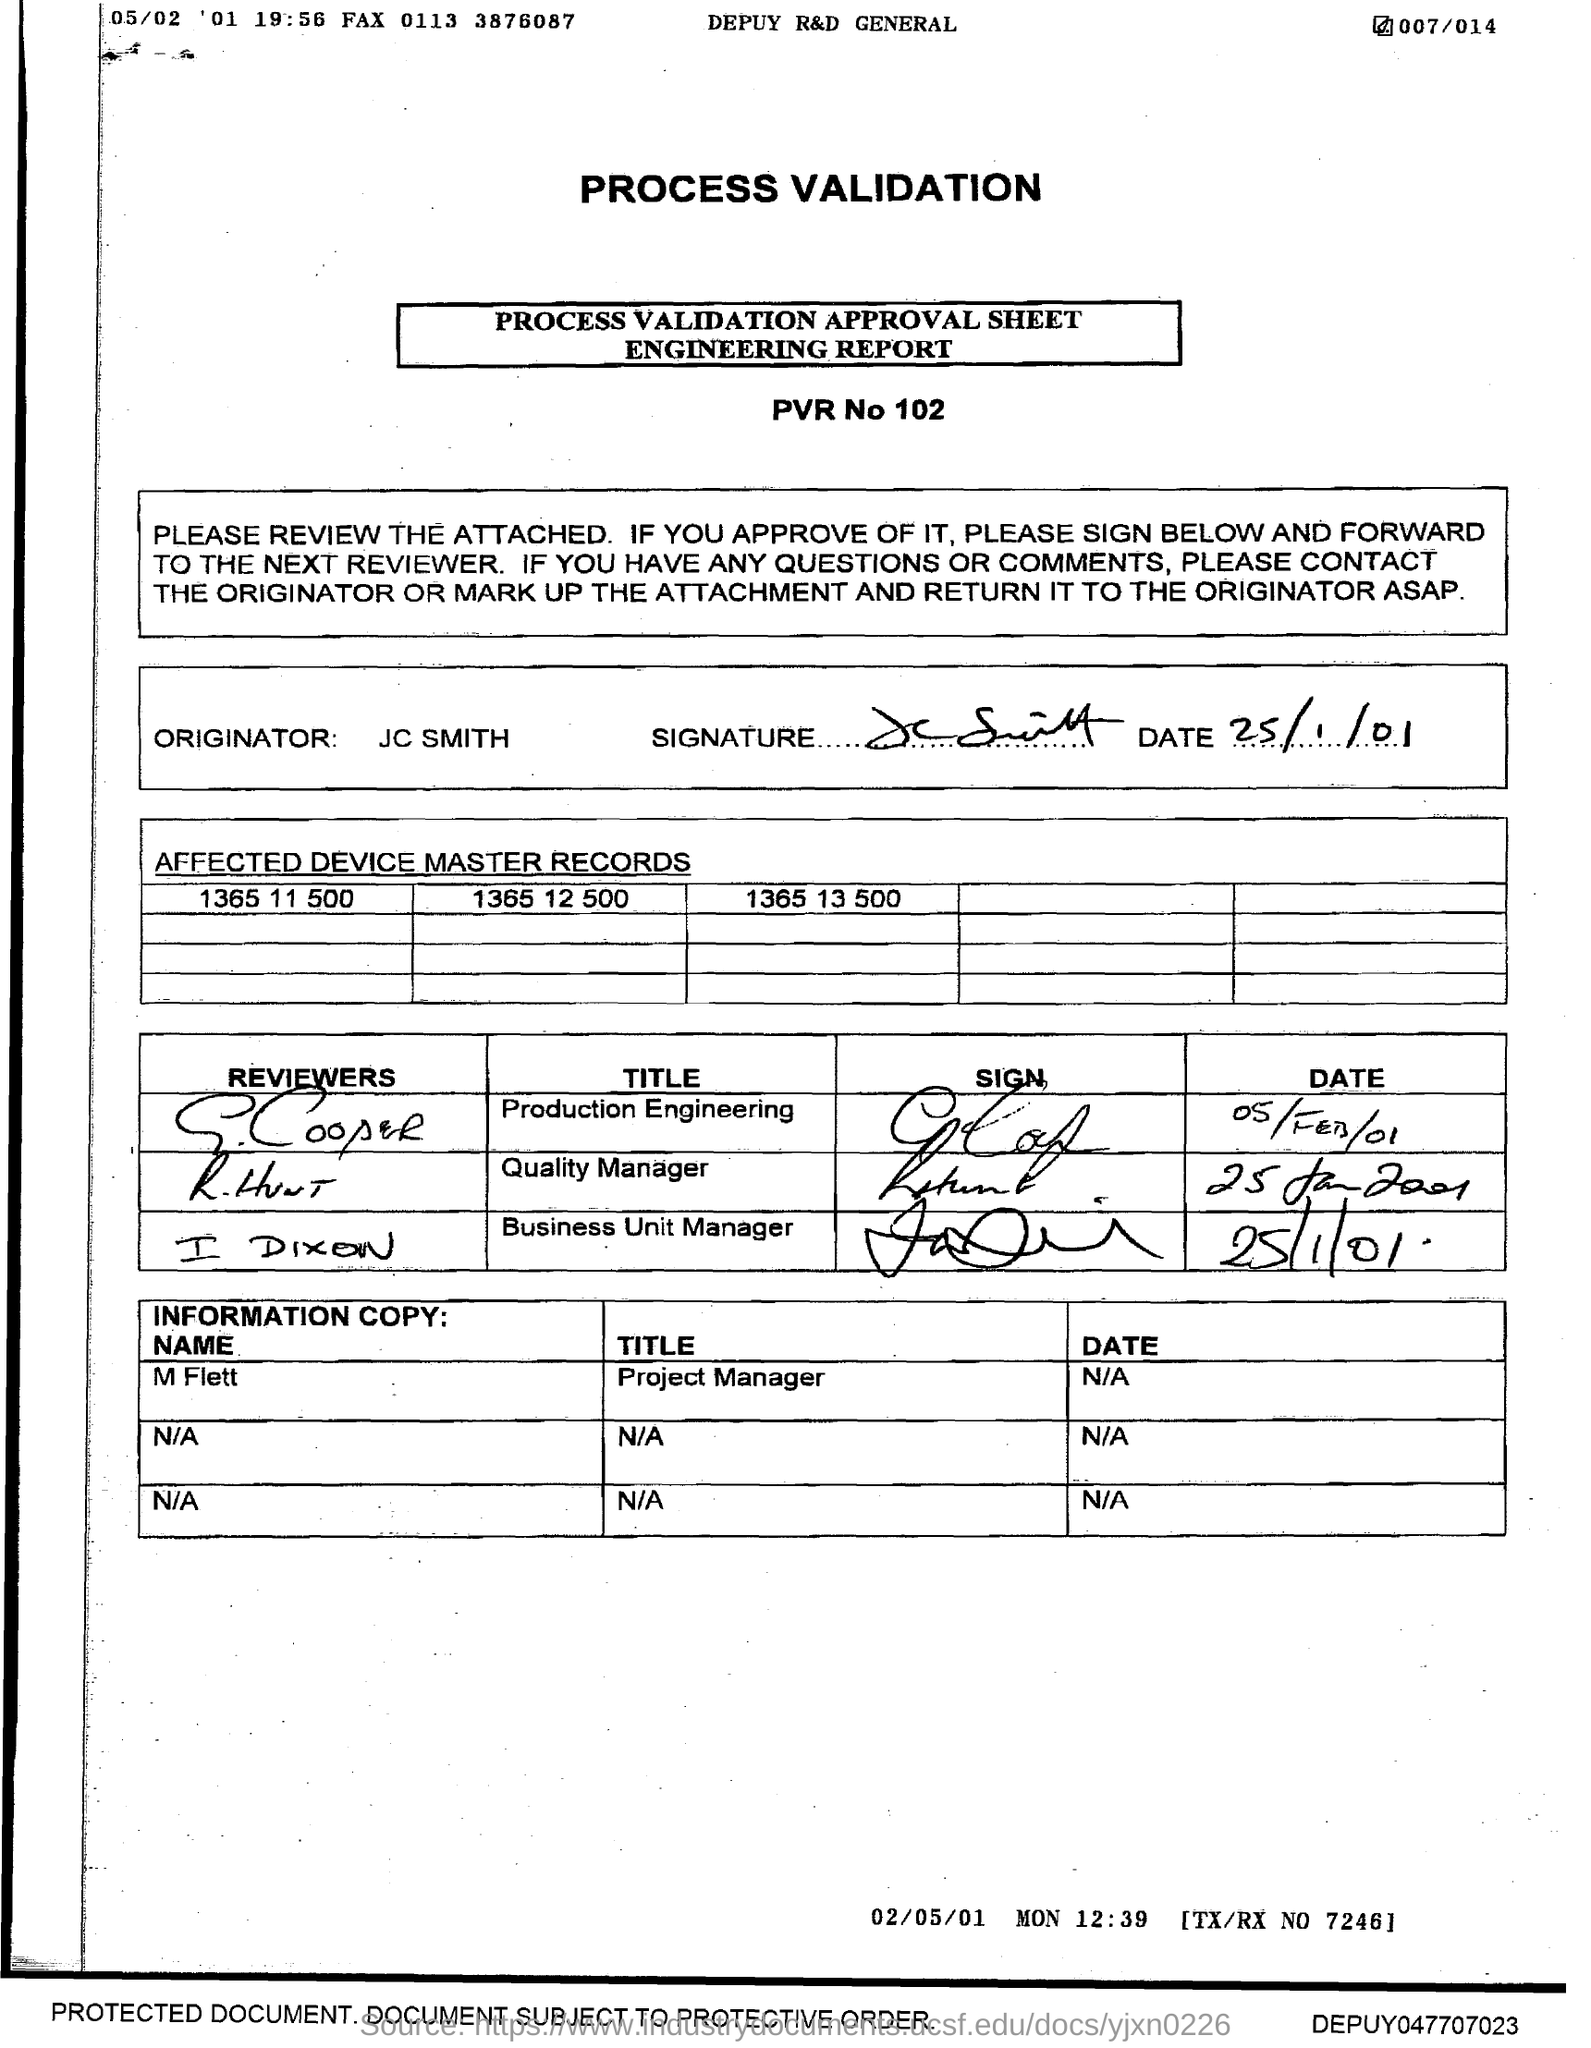Give some essential details in this illustration. The date signed by JC Smith is January 25, 2001. The Originator mentioned in the approval sheet is JC SMITH. The PVR mentioned in the approval sheet is 102. 